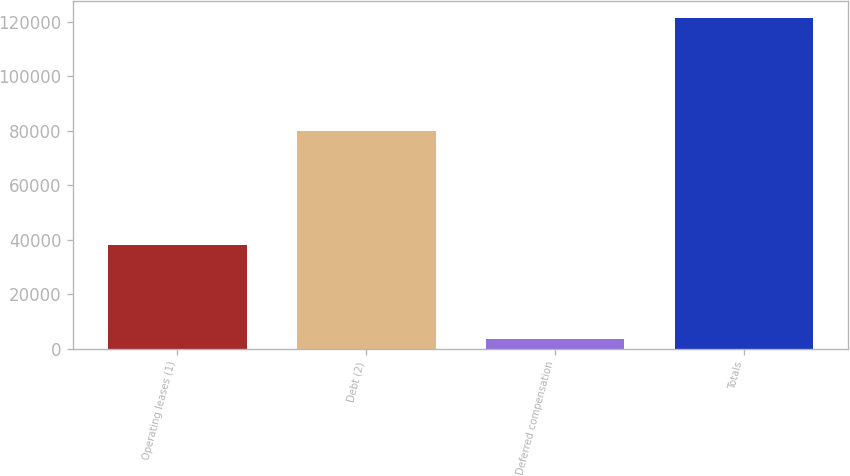<chart> <loc_0><loc_0><loc_500><loc_500><bar_chart><fcel>Operating leases (1)<fcel>Debt (2)<fcel>Deferred compensation<fcel>Totals<nl><fcel>38100<fcel>80000<fcel>3500<fcel>121600<nl></chart> 